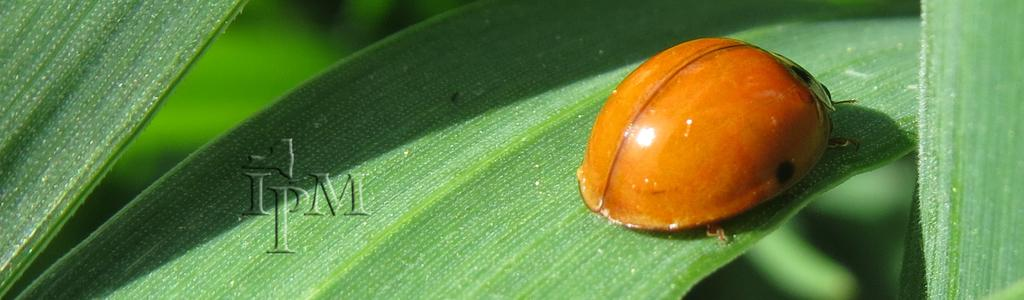What is present in the image? There is an insect in the image. Where is the insect located? The insect is on a leaf. What is the color of the insect? The insect is orange in color. What can be seen in the background of the image? There are green leaves in the background of the image. What type of fruit is the insect holding in the image? There is no fruit present in the image, and the insect is not holding anything. 